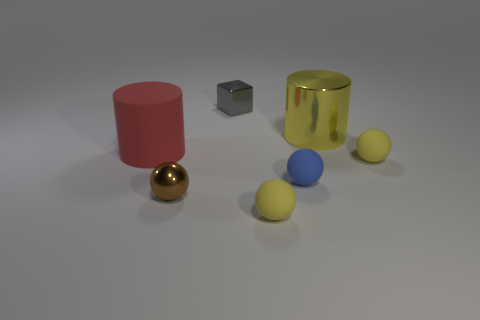Subtract all tiny blue rubber balls. How many balls are left? 3 Add 2 yellow cylinders. How many objects exist? 9 Subtract all yellow spheres. How many spheres are left? 2 Subtract 2 balls. How many balls are left? 2 Subtract all gray cylinders. How many yellow balls are left? 2 Subtract all cubes. How many objects are left? 6 Subtract 0 gray cylinders. How many objects are left? 7 Subtract all brown cylinders. Subtract all cyan blocks. How many cylinders are left? 2 Subtract all tiny brown metal spheres. Subtract all large shiny cylinders. How many objects are left? 5 Add 4 yellow cylinders. How many yellow cylinders are left? 5 